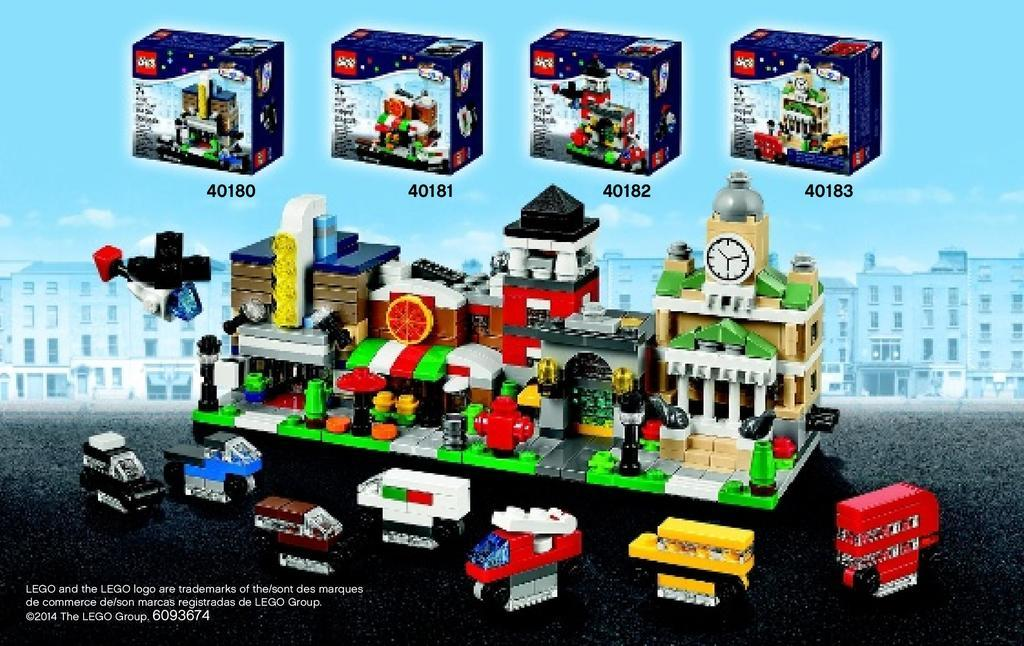What is the main subject of the poster in the image? The poster has the number and pictures of a LEGO puzzle, as well as pictures of toys, boxes, and buildings. What type of toys are depicted on the poster? The poster has pictures of toys, but the specific types of toys cannot be determined from the image. What is visible in the background of the image? The sky is visible in the background of the image. Is there any additional information or branding on the image? Yes, there is a watermark in the bottom left corner of the image. What day of the week is it in the image? The day of the week cannot be determined from the image, as it only shows a poster with LEGO puzzle images and the sky in the background. How many daughters are visible in the image? There are no people, including daughters, present in the image. 